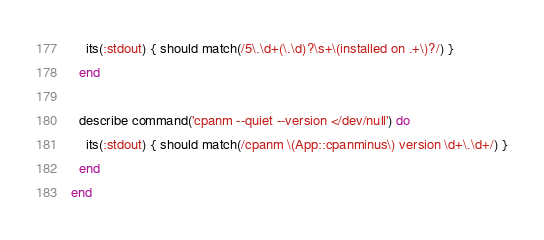<code> <loc_0><loc_0><loc_500><loc_500><_Ruby_>    its(:stdout) { should match(/5\.\d+(\.\d)?\s+\(installed on .+\)?/) }
  end

  describe command('cpanm --quiet --version </dev/null') do
    its(:stdout) { should match(/cpanm \(App::cpanminus\) version \d+\.\d+/) }
  end
end
</code> 